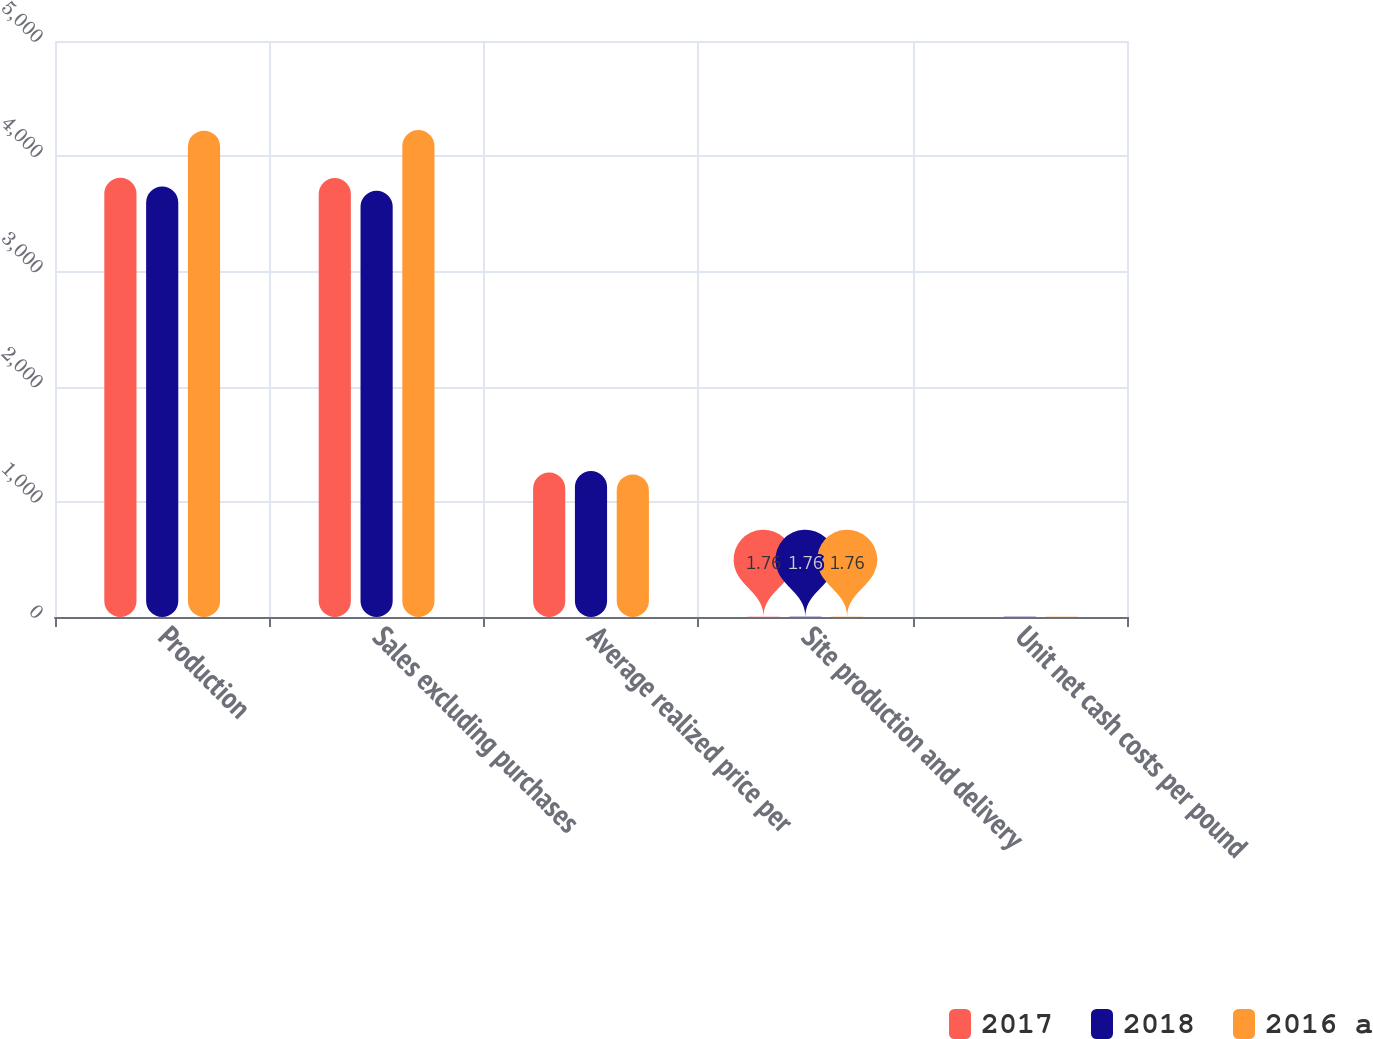<chart> <loc_0><loc_0><loc_500><loc_500><stacked_bar_chart><ecel><fcel>Production<fcel>Sales excluding purchases<fcel>Average realized price per<fcel>Site production and delivery<fcel>Unit net cash costs per pound<nl><fcel>2017<fcel>3813<fcel>3811<fcel>1254<fcel>1.76<fcel>1.07<nl><fcel>2018<fcel>3737<fcel>3700<fcel>1268<fcel>1.6<fcel>1.19<nl><fcel>2016 a<fcel>4222<fcel>4227<fcel>1238<fcel>1.42<fcel>1.26<nl></chart> 